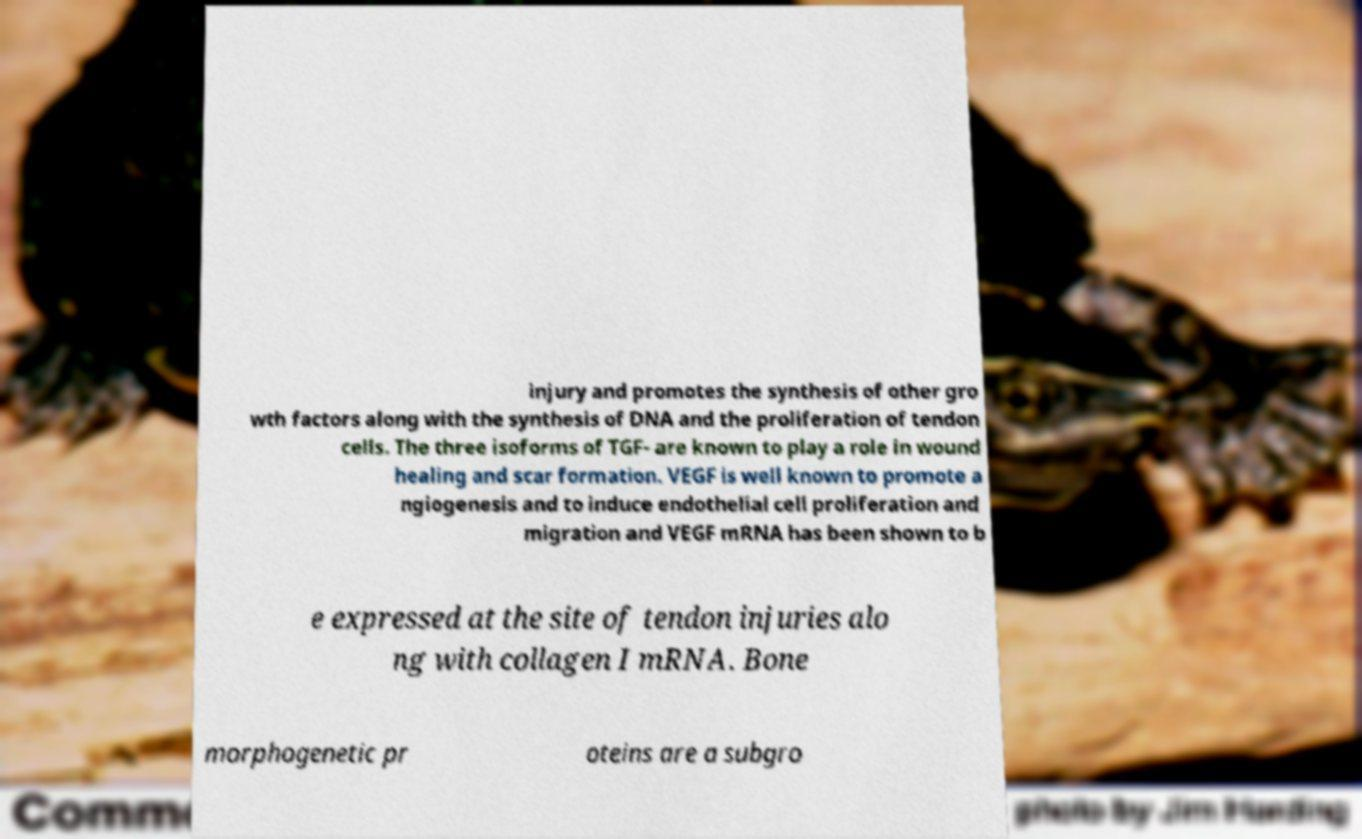Can you read and provide the text displayed in the image?This photo seems to have some interesting text. Can you extract and type it out for me? injury and promotes the synthesis of other gro wth factors along with the synthesis of DNA and the proliferation of tendon cells. The three isoforms of TGF- are known to play a role in wound healing and scar formation. VEGF is well known to promote a ngiogenesis and to induce endothelial cell proliferation and migration and VEGF mRNA has been shown to b e expressed at the site of tendon injuries alo ng with collagen I mRNA. Bone morphogenetic pr oteins are a subgro 